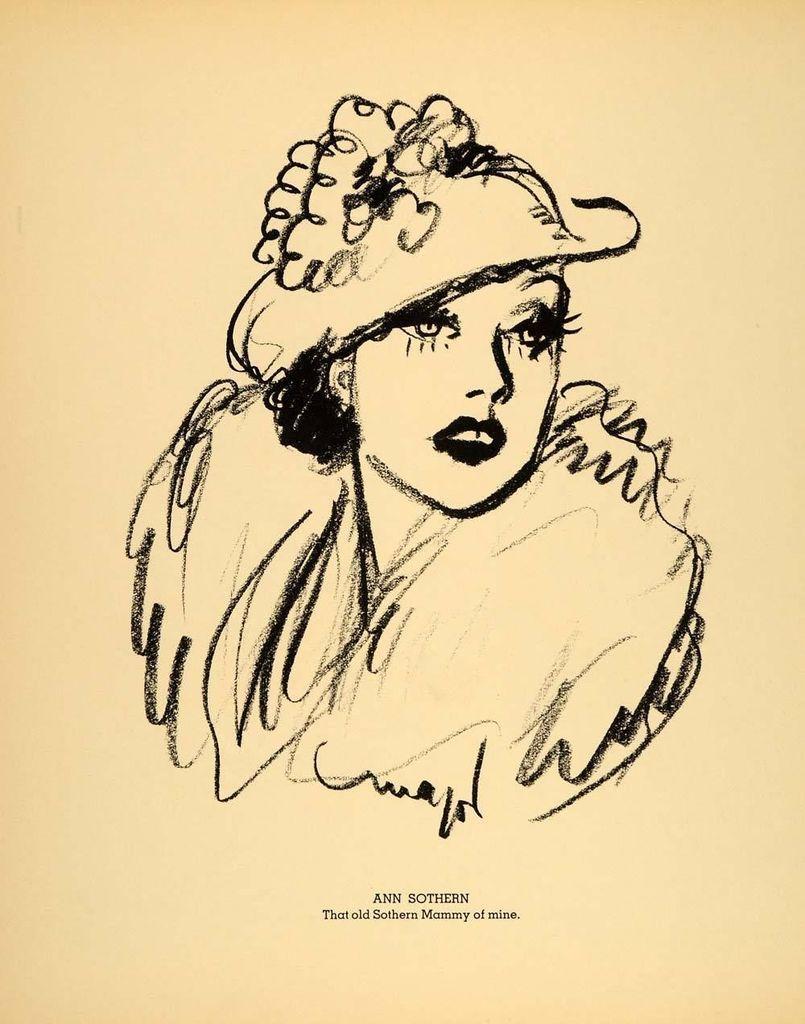Could you give a brief overview of what you see in this image? In this image I can see a crayon sketch of a woman and at the bottom of the image I can see some text. 